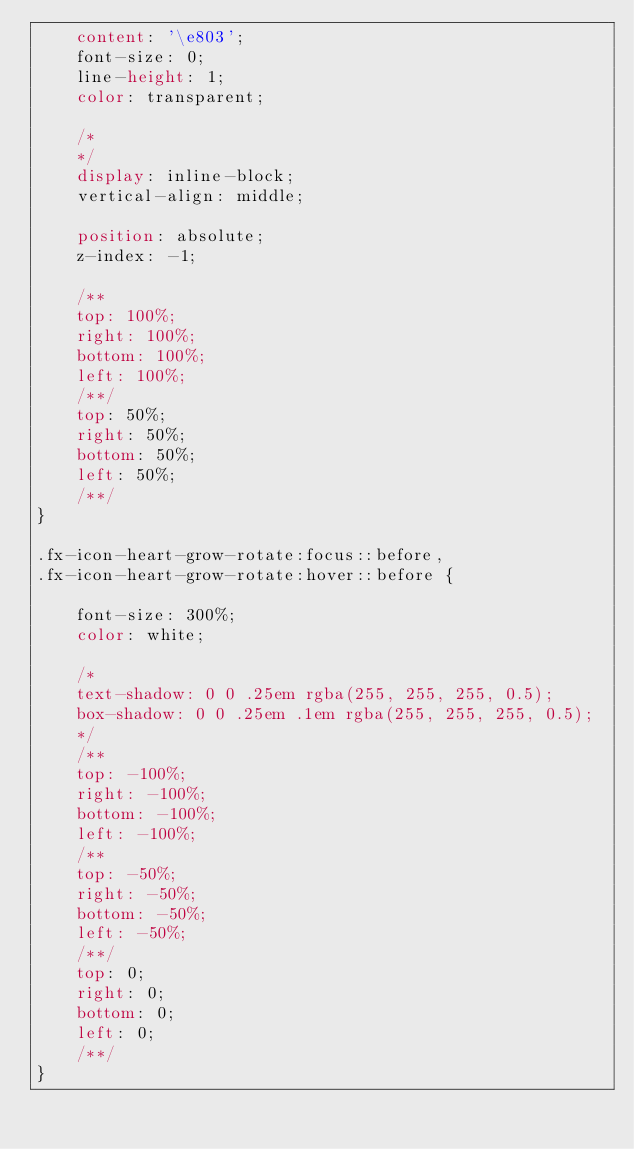Convert code to text. <code><loc_0><loc_0><loc_500><loc_500><_CSS_>    content: '\e803';
    font-size: 0;
    line-height: 1;
    color: transparent;
    
    /*
    */
    display: inline-block;
    vertical-align: middle;
    
    position: absolute;
    z-index: -1;
    
    /**
    top: 100%;
    right: 100%;
    bottom: 100%;
    left: 100%;
    /**/
    top: 50%;
    right: 50%;
    bottom: 50%;
    left: 50%;
    /**/
}

.fx-icon-heart-grow-rotate:focus::before,
.fx-icon-heart-grow-rotate:hover::before {
    
    font-size: 300%;
    color: white;
    
    /*
    text-shadow: 0 0 .25em rgba(255, 255, 255, 0.5);
    box-shadow: 0 0 .25em .1em rgba(255, 255, 255, 0.5);
    */
    /**
    top: -100%;
    right: -100%;
    bottom: -100%;
    left: -100%;
    /**
    top: -50%;
    right: -50%;
    bottom: -50%;
    left: -50%;
    /**/
    top: 0;
    right: 0;
    bottom: 0;
    left: 0;
    /**/
}
</code> 